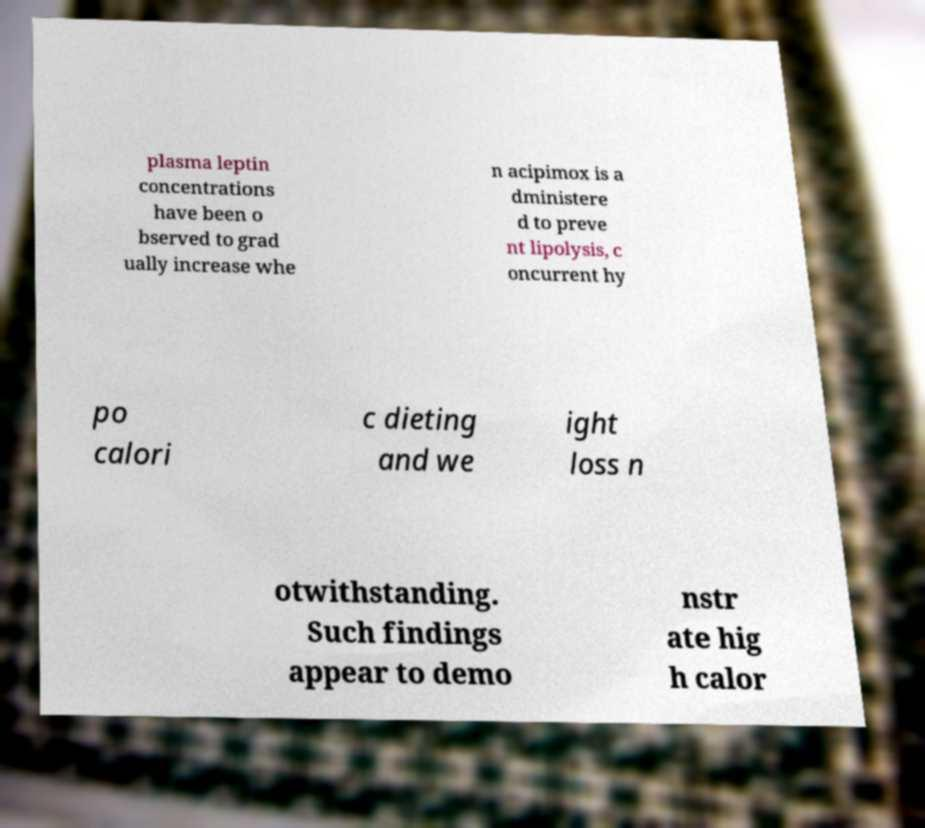Could you extract and type out the text from this image? plasma leptin concentrations have been o bserved to grad ually increase whe n acipimox is a dministere d to preve nt lipolysis, c oncurrent hy po calori c dieting and we ight loss n otwithstanding. Such findings appear to demo nstr ate hig h calor 